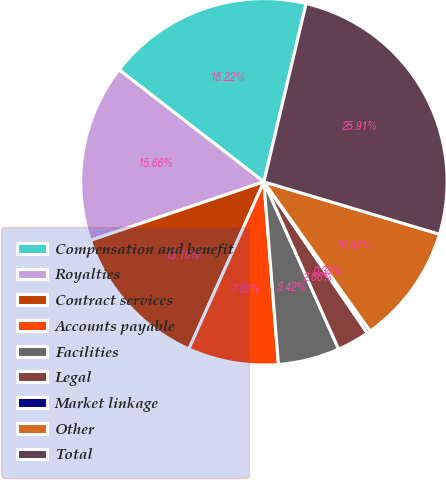<chart> <loc_0><loc_0><loc_500><loc_500><pie_chart><fcel>Compensation and benefit<fcel>Royalties<fcel>Contract services<fcel>Accounts payable<fcel>Facilities<fcel>Legal<fcel>Market linkage<fcel>Other<fcel>Total<nl><fcel>18.22%<fcel>15.66%<fcel>13.1%<fcel>7.98%<fcel>5.42%<fcel>2.86%<fcel>0.3%<fcel>10.54%<fcel>25.91%<nl></chart> 